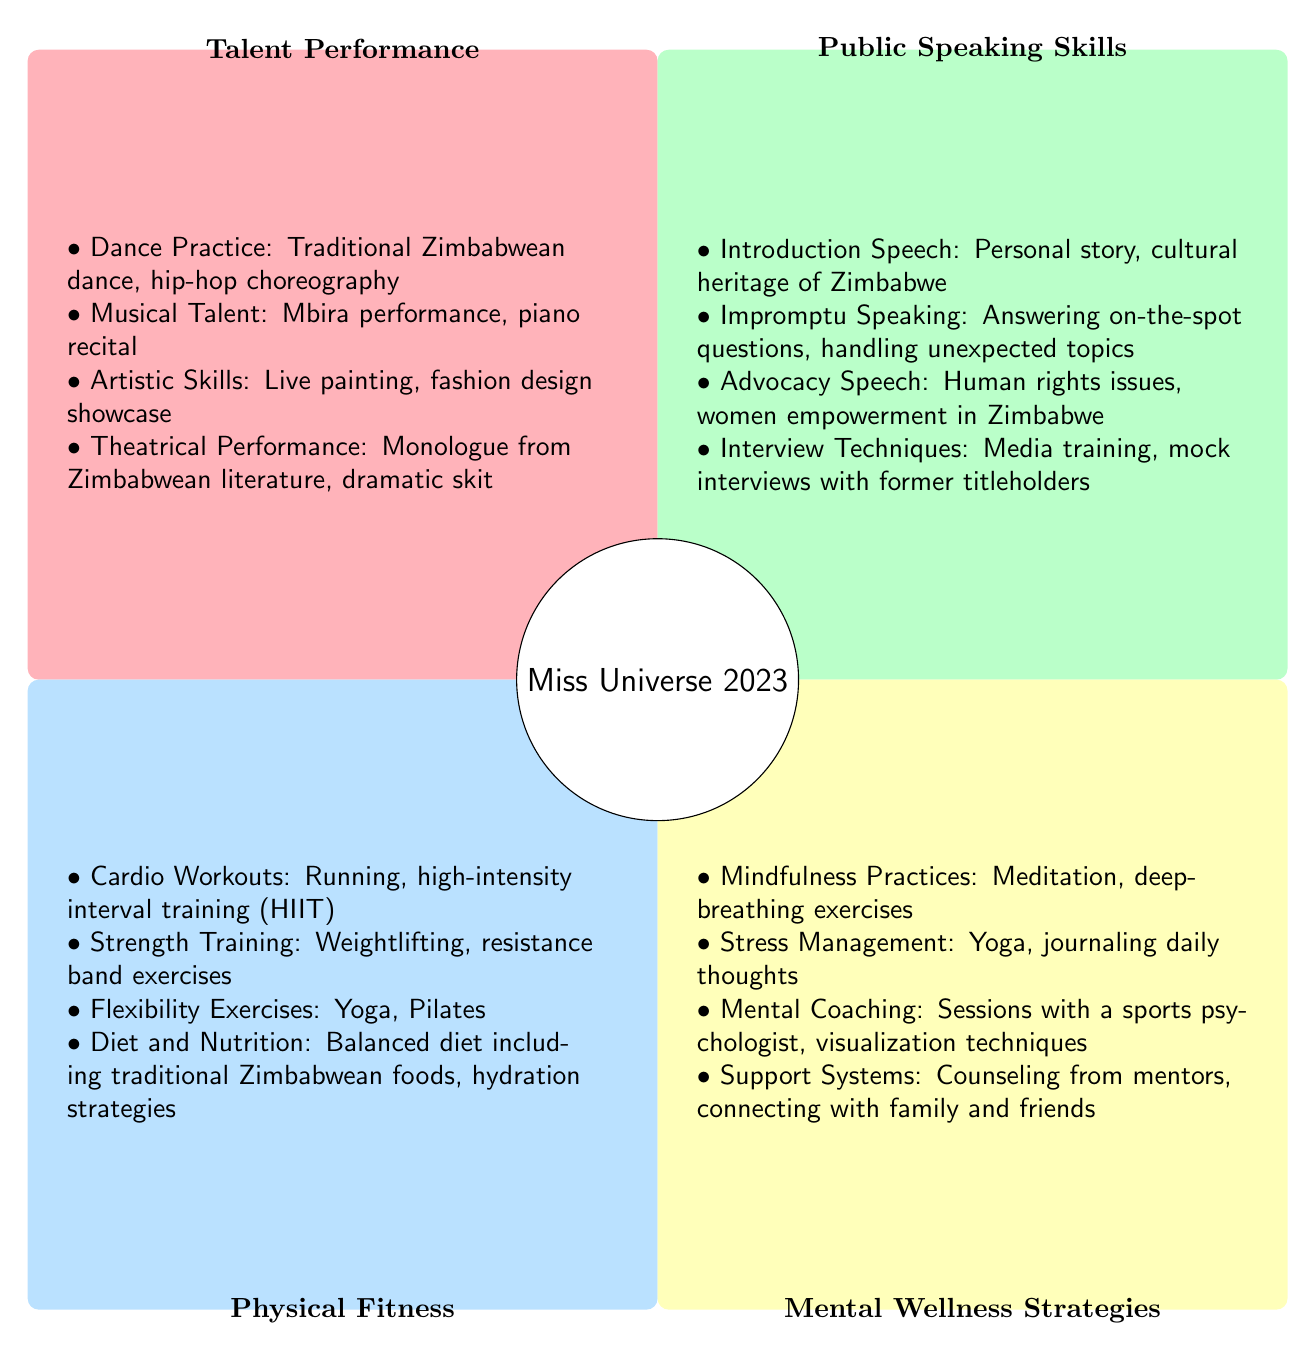What are the elements listed under Talent Performance? The elements listed under "Talent Performance" in Quadrant 1 include Dance Practice, Musical Talent, Artistic Skills, and Theatrical Performance. Each of these elements is defined with specific activities, such as traditional Zimbabwean dance and mbira performance.
Answer: Dance Practice, Musical Talent, Artistic Skills, Theatrical Performance How many elements are listed in the Public Speaking Skills quadrant? In Quadrant 2, the elements listed include Introduction Speech, Impromptu Speaking, Advocacy Speech, and Interview Techniques. This totals to four different elements.
Answer: 4 What type of exercises are included in Physical Fitness? The "Physical Fitness" quadrant (Quadrant 3) includes Cardio Workouts, Strength Training, Flexibility Exercises, and Diet and Nutrition, indicating a comprehensive approach to physical fitness that combines various types of training and dietary considerations.
Answer: Cardio Workouts, Strength Training, Flexibility Exercises, Diet and Nutrition Which quadrant contains Mental Coaching? "Mental Coaching" is a strategy listed under the "Mental Wellness Strategies" quadrant in Quadrant 4. This quadrant focuses on various mental health support systems, including coaching and mindfulness practices.
Answer: Mental Wellness Strategies What are the key focus areas for Public Speaking Skills? The key focus areas for "Public Speaking Skills" include Introduction Speech, Impromptu Speaking, Advocacy Speech, and Interview Techniques, all designed to enhance the participant's communication and presentation abilities.
Answer: Introduction Speech, Impromptu Speaking, Advocacy Speech, Interview Techniques How does Dance Practice relate to the overall talent preparation? Dance Practice, as listed under Talent Performance, showcases cultural elements important to the pageant, reflecting heritage and individual expression, which are valued attributes in pageant competitions.
Answer: Cultural elements, heritage, individual expression Which two quadrants focus on performance and communication skills? The quadrants that focus on performance and communication skills are Quadrant 1, "Talent Performance," and Quadrant 2, "Public Speaking Skills." These quadrants emphasize artistic and communicative abilities that are crucial for pageant contestants.
Answer: Talent Performance, Public Speaking Skills What strategies are included under Mental Wellness? The strategies included under "Mental Wellness Strategies" are Mindfulness Practices, Stress Management, Mental Coaching, and Support Systems, all aimed at promoting emotional health and resilience during the competition.
Answer: Mindfulness Practices, Stress Management, Mental Coaching, Support Systems 